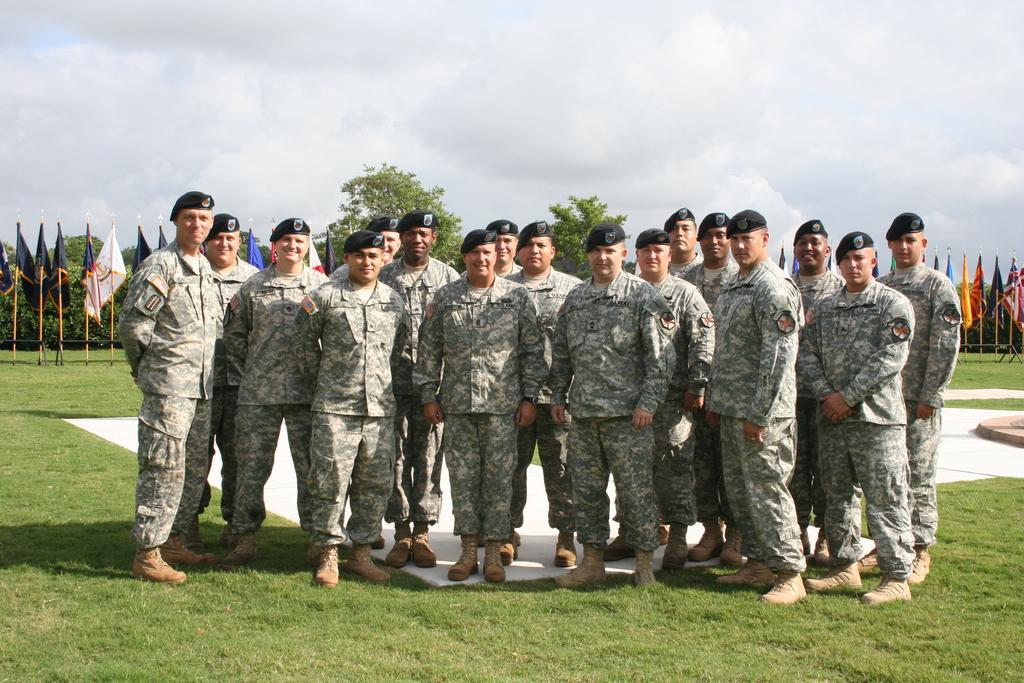Please provide a concise description of this image. In this image we can see a group of people standing wearing a soldier costume. And in the bottom we can see the grass. And on the left side, we can see the flags. and behind we can see trees. And clouds in the sky. 